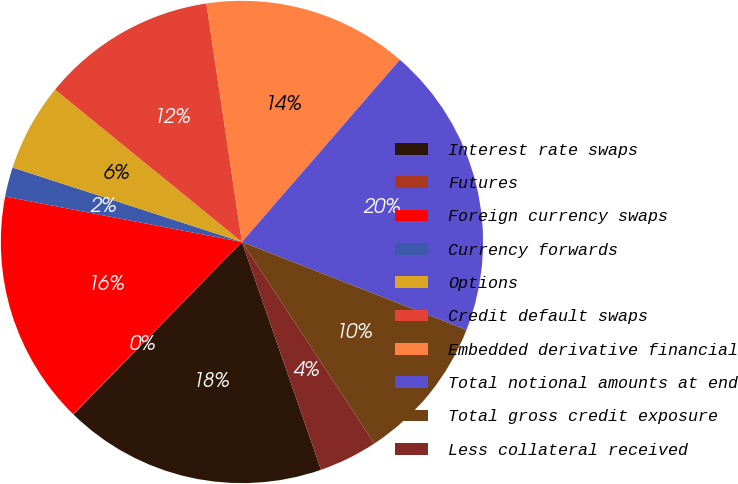<chart> <loc_0><loc_0><loc_500><loc_500><pie_chart><fcel>Interest rate swaps<fcel>Futures<fcel>Foreign currency swaps<fcel>Currency forwards<fcel>Options<fcel>Credit default swaps<fcel>Embedded derivative financial<fcel>Total notional amounts at end<fcel>Total gross credit exposure<fcel>Less collateral received<nl><fcel>17.63%<fcel>0.03%<fcel>15.67%<fcel>1.98%<fcel>5.89%<fcel>11.76%<fcel>13.72%<fcel>19.58%<fcel>9.8%<fcel>3.94%<nl></chart> 